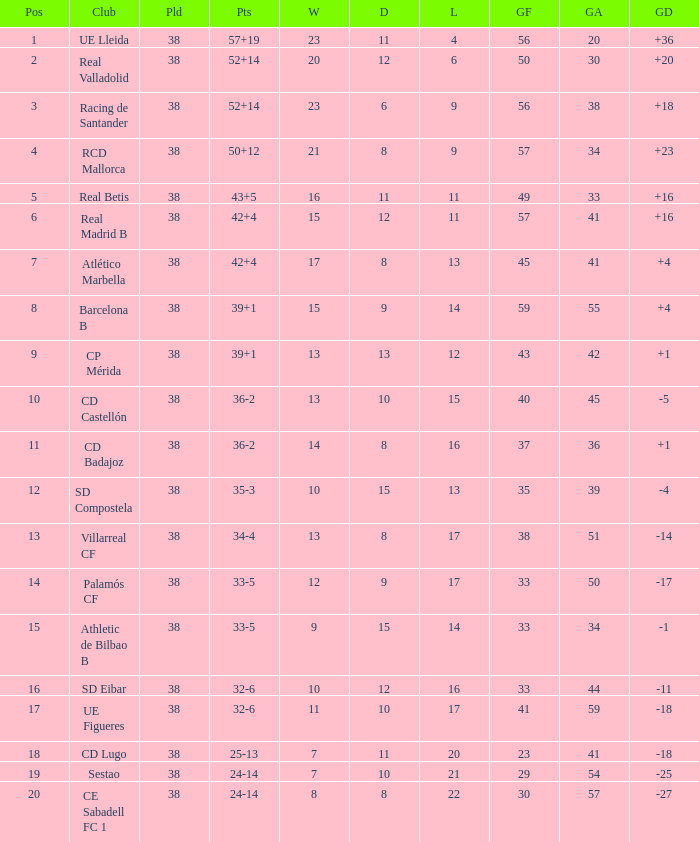What is the average goal difference with 51 goals scored against and less than 17 losses? None. Would you be able to parse every entry in this table? {'header': ['Pos', 'Club', 'Pld', 'Pts', 'W', 'D', 'L', 'GF', 'GA', 'GD'], 'rows': [['1', 'UE Lleida', '38', '57+19', '23', '11', '4', '56', '20', '+36'], ['2', 'Real Valladolid', '38', '52+14', '20', '12', '6', '50', '30', '+20'], ['3', 'Racing de Santander', '38', '52+14', '23', '6', '9', '56', '38', '+18'], ['4', 'RCD Mallorca', '38', '50+12', '21', '8', '9', '57', '34', '+23'], ['5', 'Real Betis', '38', '43+5', '16', '11', '11', '49', '33', '+16'], ['6', 'Real Madrid B', '38', '42+4', '15', '12', '11', '57', '41', '+16'], ['7', 'Atlético Marbella', '38', '42+4', '17', '8', '13', '45', '41', '+4'], ['8', 'Barcelona B', '38', '39+1', '15', '9', '14', '59', '55', '+4'], ['9', 'CP Mérida', '38', '39+1', '13', '13', '12', '43', '42', '+1'], ['10', 'CD Castellón', '38', '36-2', '13', '10', '15', '40', '45', '-5'], ['11', 'CD Badajoz', '38', '36-2', '14', '8', '16', '37', '36', '+1'], ['12', 'SD Compostela', '38', '35-3', '10', '15', '13', '35', '39', '-4'], ['13', 'Villarreal CF', '38', '34-4', '13', '8', '17', '38', '51', '-14'], ['14', 'Palamós CF', '38', '33-5', '12', '9', '17', '33', '50', '-17'], ['15', 'Athletic de Bilbao B', '38', '33-5', '9', '15', '14', '33', '34', '-1'], ['16', 'SD Eibar', '38', '32-6', '10', '12', '16', '33', '44', '-11'], ['17', 'UE Figueres', '38', '32-6', '11', '10', '17', '41', '59', '-18'], ['18', 'CD Lugo', '38', '25-13', '7', '11', '20', '23', '41', '-18'], ['19', 'Sestao', '38', '24-14', '7', '10', '21', '29', '54', '-25'], ['20', 'CE Sabadell FC 1', '38', '24-14', '8', '8', '22', '30', '57', '-27']]} 